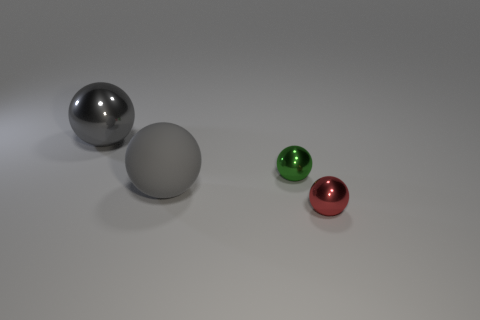Subtract 1 spheres. How many spheres are left? 3 Add 3 tiny spheres. How many objects exist? 7 Subtract all gray objects. Subtract all large things. How many objects are left? 0 Add 1 red spheres. How many red spheres are left? 2 Add 4 small purple metal cubes. How many small purple metal cubes exist? 4 Subtract 0 brown cylinders. How many objects are left? 4 